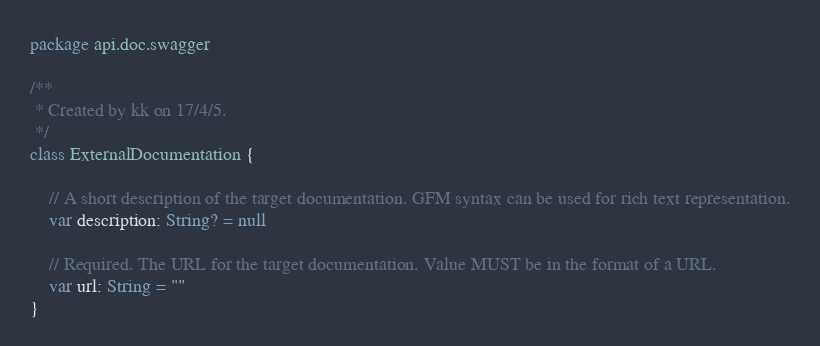<code> <loc_0><loc_0><loc_500><loc_500><_Kotlin_>package api.doc.swagger

/**
 * Created by kk on 17/4/5.
 */
class ExternalDocumentation {

    // A short description of the target documentation. GFM syntax can be used for rich text representation.
    var description: String? = null

    // Required. The URL for the target documentation. Value MUST be in the format of a URL.
    var url: String = ""
}</code> 